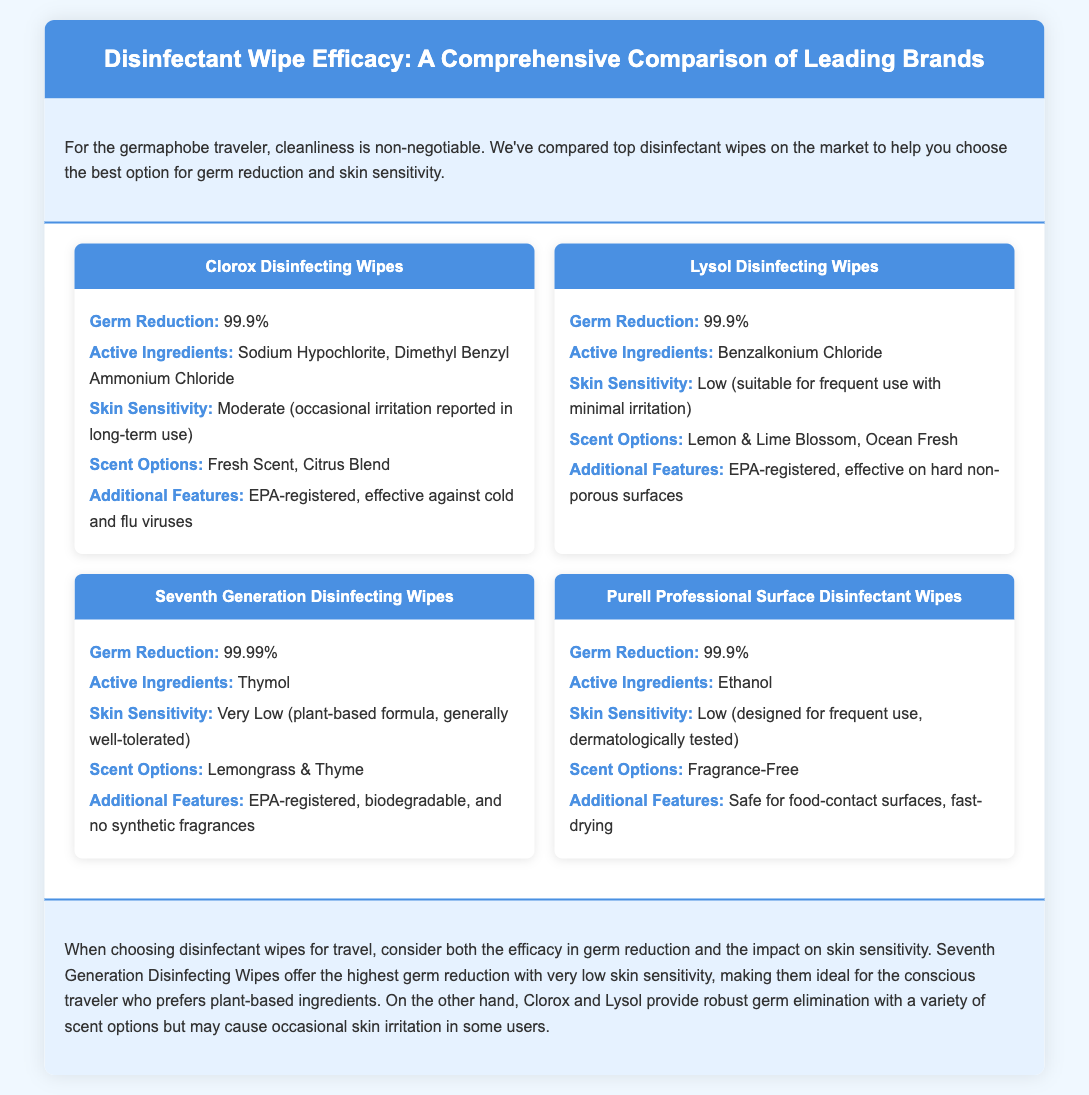What is the germ reduction percentage for Lysol Disinfecting Wipes? The germ reduction percentage for Lysol Disinfecting Wipes is 99.9%.
Answer: 99.9% What are the active ingredients in Clorox Disinfecting Wipes? The active ingredients in Clorox Disinfecting Wipes are Sodium Hypochlorite and Dimethyl Benzyl Ammonium Chloride.
Answer: Sodium Hypochlorite, Dimethyl Benzyl Ammonium Chloride Which disinfectant wipe has the lowest skin sensitivity? Seventh Generation Disinfecting Wipes have the lowest skin sensitivity, categorized as very low.
Answer: Very Low What additional feature do Purell Professional Surface Disinfectant Wipes offer? Purell Professional Surface Disinfectant Wipes are safe for food-contact surfaces and fast-drying.
Answer: Safe for food-contact surfaces, fast-drying Which brand offers biodegradable wipes? Seventh Generation Disinfecting Wipes are the brand that offers biodegradable wipes.
Answer: Seventh Generation How many scent options are available for Lysol Disinfecting Wipes? Lysol Disinfecting Wipes have two scent options available: Lemon & Lime Blossom and Ocean Fresh.
Answer: Two Which disinfectant wipe provides the highest germ reduction? Seventh Generation Disinfecting Wipes provide the highest germ reduction at 99.99%.
Answer: 99.99% What is the scent option for Purell Professional Surface Disinfectant Wipes? The scent option for Purell Professional Surface Disinfectant Wipes is Fragrance-Free.
Answer: Fragrance-Free 